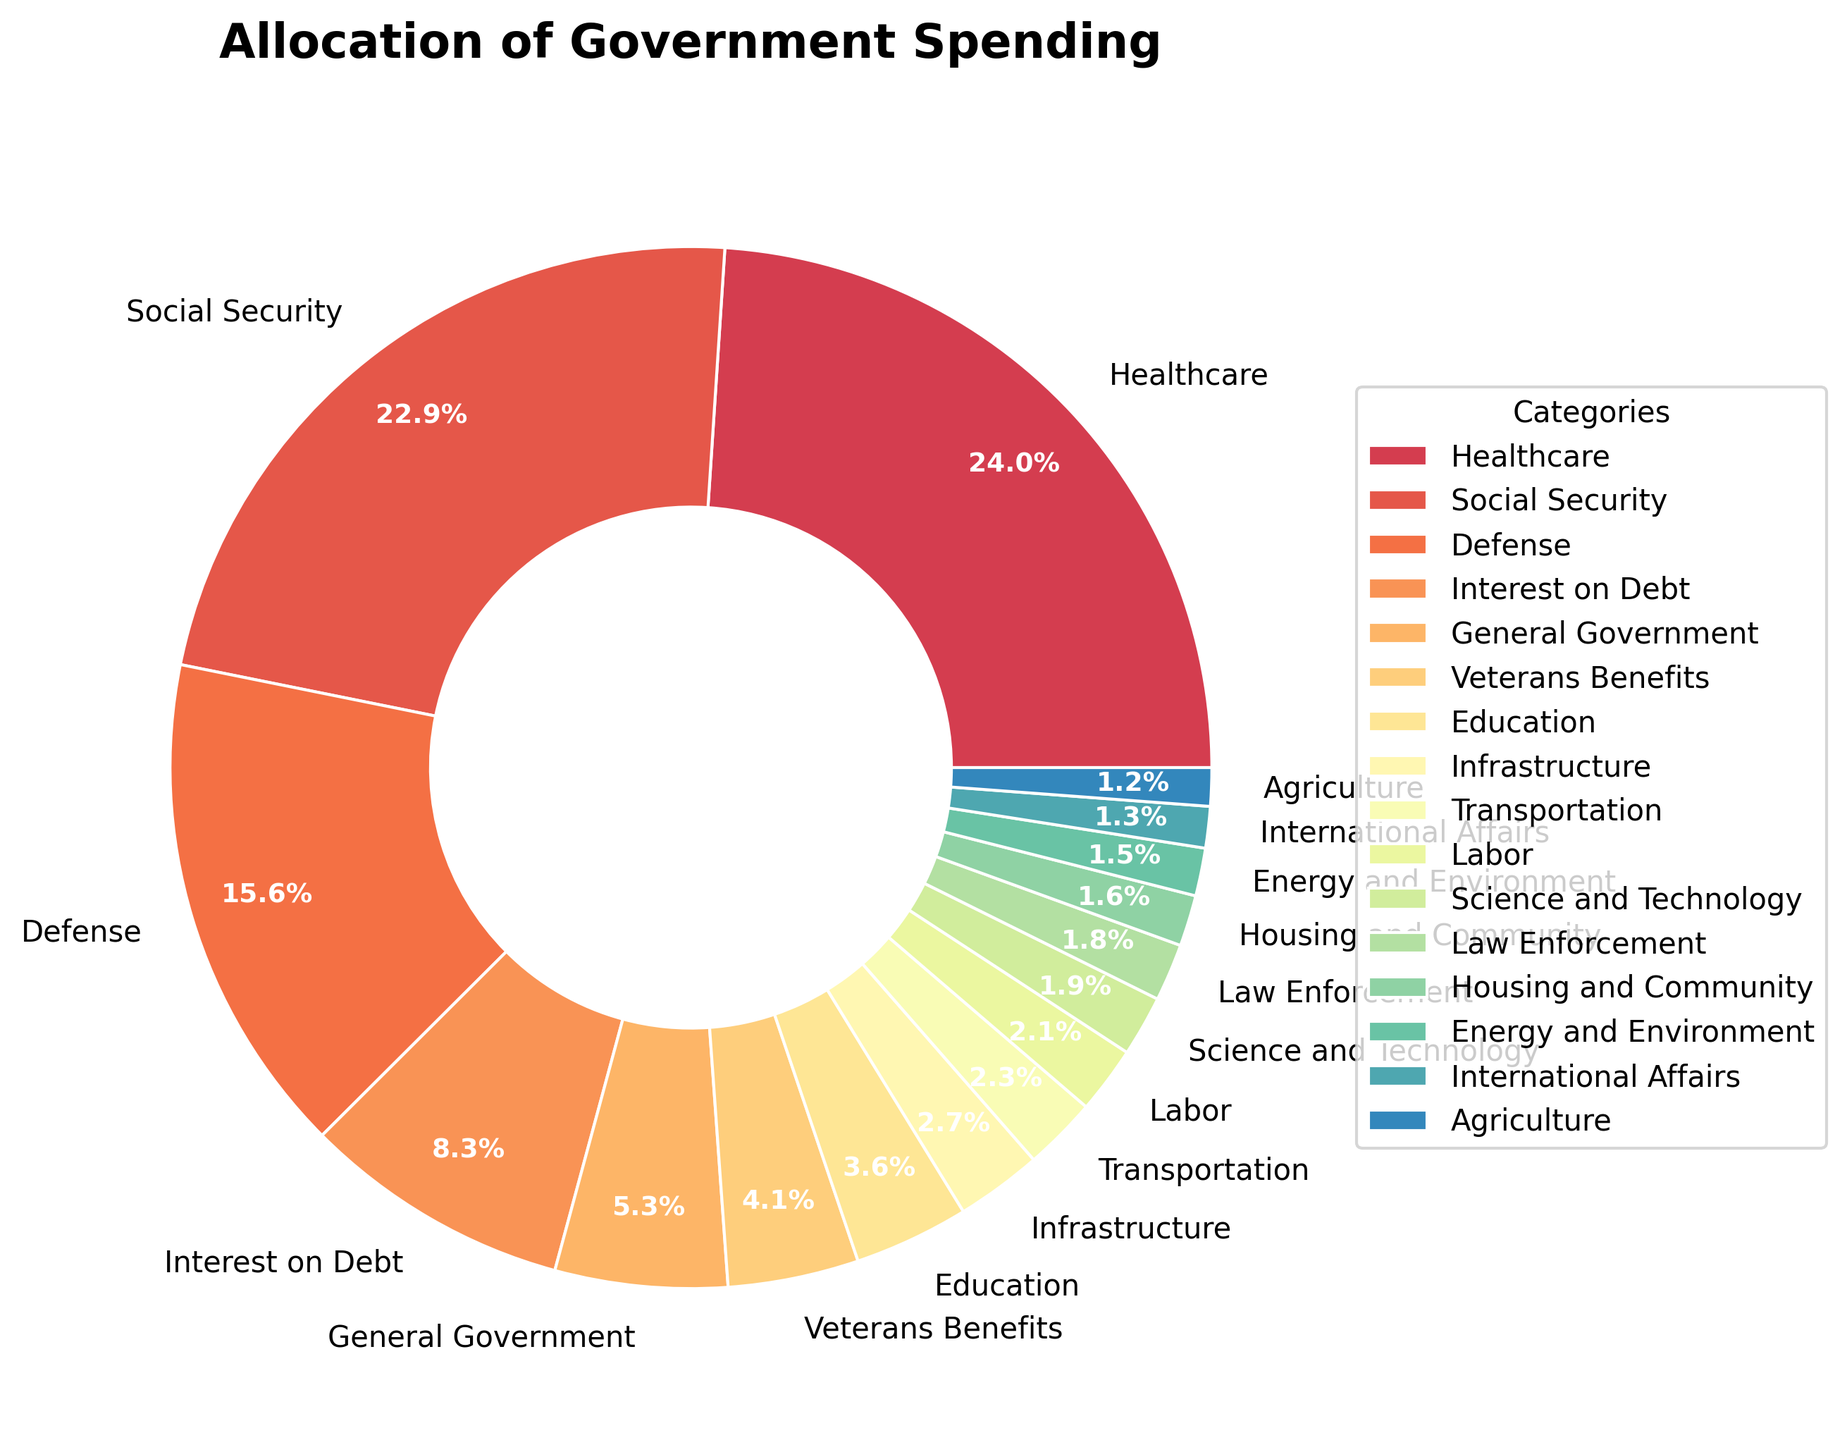What percentage of the budget is allocated to Education and Social Security combined? To find the combined percentage, add the allocation for Education (3.6%) and Social Security (23.1%). Sum: 3.6 + 23.1 = 26.7%
Answer: 26.7% Which category receives more funding: Defense or Interest on Debt? Compare the percentages for Defense (15.8%) and Interest on Debt (8.4%). Defense clearly receives more funding.
Answer: Defense Which category has the smallest allocation? By looking at the chart, the smallest slice corresponds to Agriculture, which is allocated 1.2%.
Answer: Agriculture What is the difference in funding between Healthcare and Defense? Subtract the percentage of Defense (15.8%) from Healthcare (24.2%). Difference: 24.2 - 15.8 = 8.4%
Answer: 8.4% How many categories have a budget allocation of less than 2%? Examine all categories and count those with less than 2%: Agriculture (1.2%), Energy and Environment (1.5%), Science and Technology (1.9%), International Affairs (1.3%), Law Enforcement (1.8%), Housing and Community (1.6%). Total: 6 categories.
Answer: 6 Is the budget allocation for Other categories (those not individually labeled) more or less than that for Transportation? The chart does not indicate a significant "Other" category. Compare to Transportation's 2.3%. Since most other categories are below this threshold, Transport is likely higher.
Answer: Less Which two categories, when combined, make up the highest percentage of the budget? By adding various combinations, it’s clear that Healthcare (24.2%) and Social Security (23.1%) combined yield the highest: 24.2 + 23.1 = 47.3%
Answer: Healthcare and Social Security Which category uses less than 5% of the budget and more funds than Agriculture? Categories below 5% are Education, Infrastructure, Veterans Benefits, Interest on Debt, Energy and Environment, Science and Technology, International Affairs, Law Enforcement, Housing and Community, Transportation, Labor, and General Government. Of these, only Veterans Benefits (4.1%) use more than Agriculture (1.2%).
Answer: Veterans Benefits 